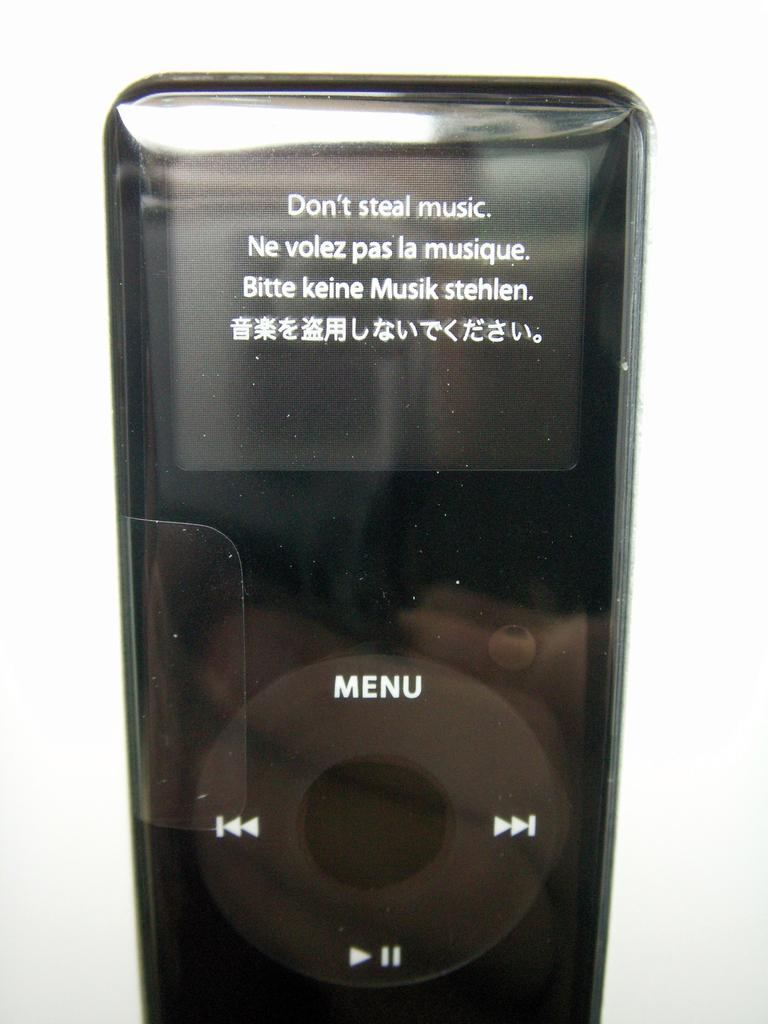<image>
Relay a brief, clear account of the picture shown. An ipod screen says don't steal music in several languages. 